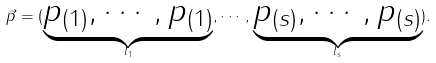Convert formula to latex. <formula><loc_0><loc_0><loc_500><loc_500>\vec { p } = ( \underbrace { p _ { ( 1 ) } , \cdots , p _ { ( 1 ) } } _ { l _ { 1 } } , \cdots , \underbrace { p _ { ( s ) } , \cdots , p _ { ( s ) } } _ { l _ { s } } ) .</formula> 